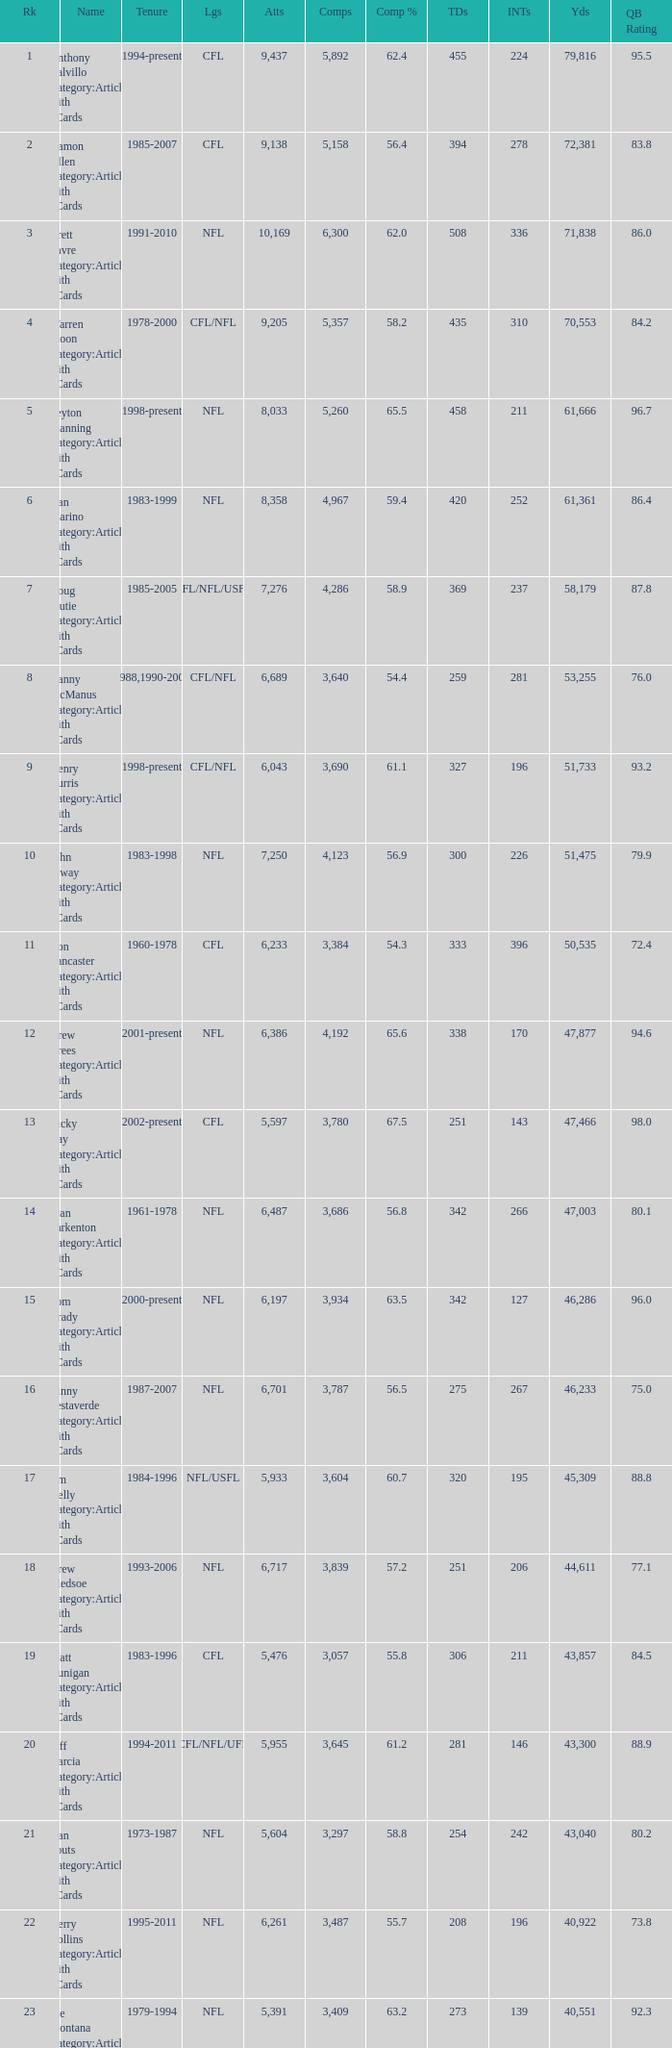What is the comp percentage when there are less than 44,611 in yardage, more than 254 touchdowns, and rank larger than 24? 54.6. 